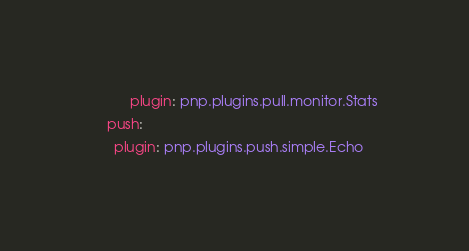<code> <loc_0><loc_0><loc_500><loc_500><_YAML_>          plugin: pnp.plugins.pull.monitor.Stats
    push:
      plugin: pnp.plugins.push.simple.Echo
</code> 